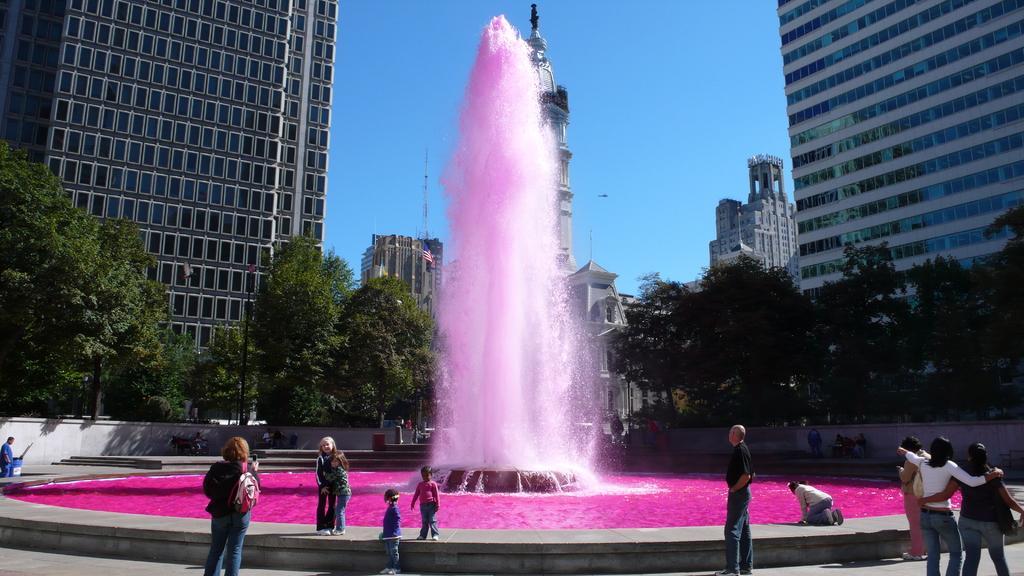In one or two sentences, can you explain what this image depicts? In this picture we can see fountain full of pink color water and around the fountain we have persons and on right side we have two woman walking and in middle man is standing and looking at fountain and on left side woman clicking a image for her children's and in the background we can see building, sky, tree, motor bike, wall and person holding drum. 